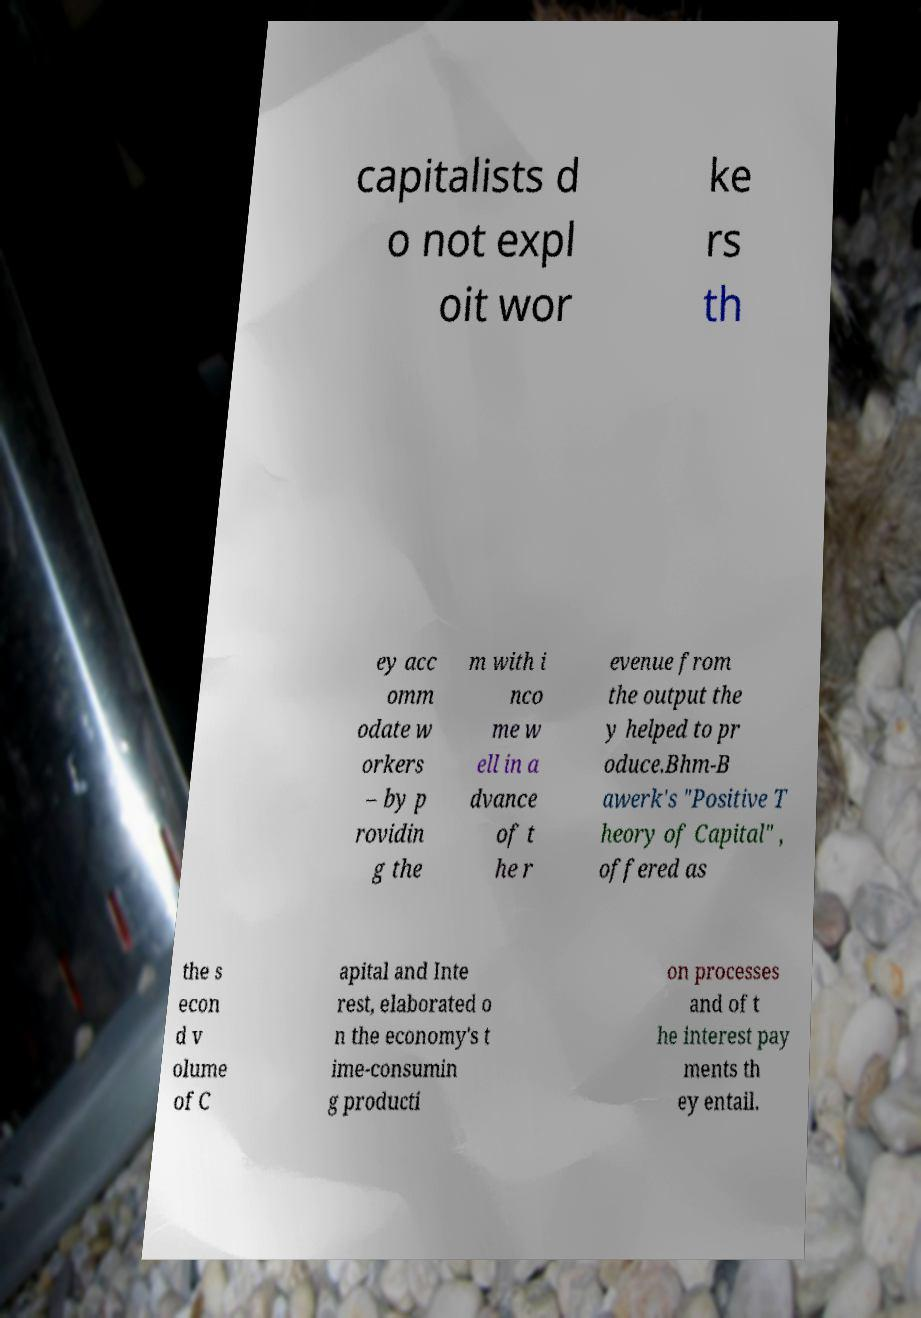For documentation purposes, I need the text within this image transcribed. Could you provide that? capitalists d o not expl oit wor ke rs th ey acc omm odate w orkers – by p rovidin g the m with i nco me w ell in a dvance of t he r evenue from the output the y helped to pr oduce.Bhm-B awerk's "Positive T heory of Capital" , offered as the s econ d v olume of C apital and Inte rest, elaborated o n the economy's t ime-consumin g producti on processes and of t he interest pay ments th ey entail. 